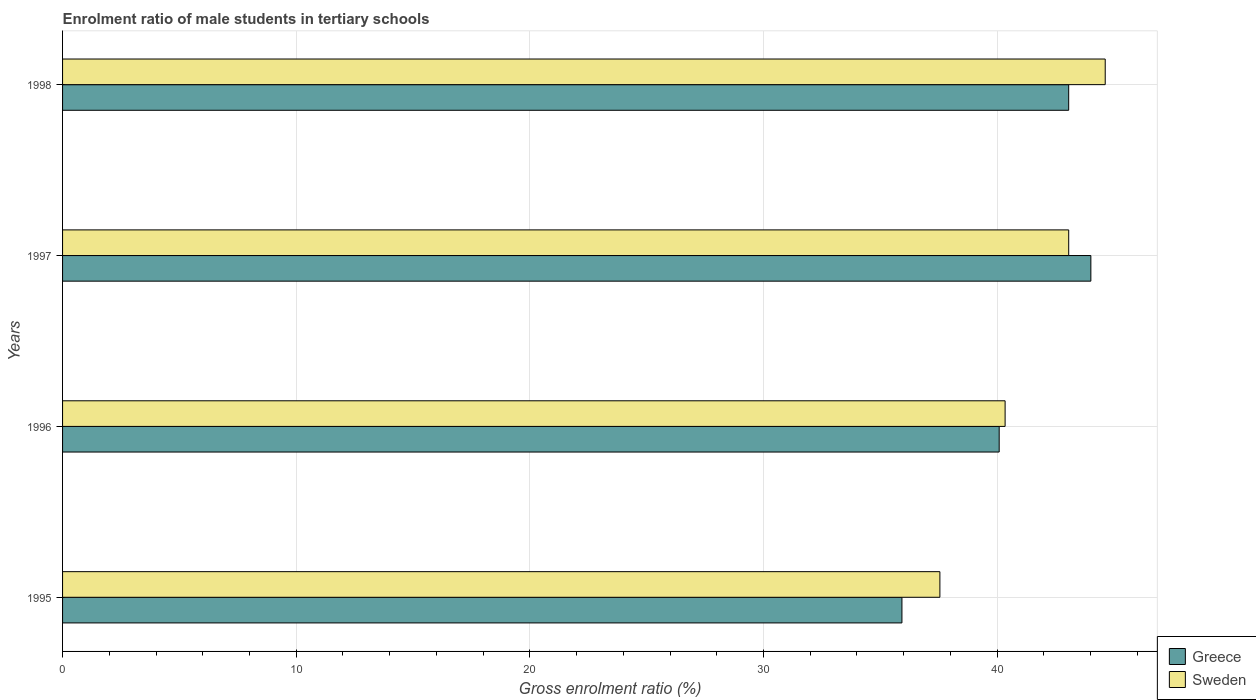How many different coloured bars are there?
Your response must be concise. 2. Are the number of bars per tick equal to the number of legend labels?
Offer a very short reply. Yes. How many bars are there on the 2nd tick from the top?
Provide a succinct answer. 2. What is the label of the 4th group of bars from the top?
Your answer should be compact. 1995. In how many cases, is the number of bars for a given year not equal to the number of legend labels?
Make the answer very short. 0. What is the enrolment ratio of male students in tertiary schools in Sweden in 1996?
Your answer should be compact. 40.34. Across all years, what is the maximum enrolment ratio of male students in tertiary schools in Greece?
Provide a succinct answer. 44.01. Across all years, what is the minimum enrolment ratio of male students in tertiary schools in Greece?
Ensure brevity in your answer.  35.93. In which year was the enrolment ratio of male students in tertiary schools in Greece minimum?
Give a very brief answer. 1995. What is the total enrolment ratio of male students in tertiary schools in Greece in the graph?
Your answer should be compact. 163.09. What is the difference between the enrolment ratio of male students in tertiary schools in Greece in 1996 and that in 1997?
Ensure brevity in your answer.  -3.92. What is the difference between the enrolment ratio of male students in tertiary schools in Sweden in 1995 and the enrolment ratio of male students in tertiary schools in Greece in 1998?
Provide a succinct answer. -5.51. What is the average enrolment ratio of male students in tertiary schools in Greece per year?
Ensure brevity in your answer.  40.77. In the year 1997, what is the difference between the enrolment ratio of male students in tertiary schools in Sweden and enrolment ratio of male students in tertiary schools in Greece?
Ensure brevity in your answer.  -0.95. In how many years, is the enrolment ratio of male students in tertiary schools in Sweden greater than 34 %?
Your answer should be very brief. 4. What is the ratio of the enrolment ratio of male students in tertiary schools in Sweden in 1996 to that in 1998?
Provide a succinct answer. 0.9. Is the enrolment ratio of male students in tertiary schools in Sweden in 1996 less than that in 1998?
Provide a succinct answer. Yes. Is the difference between the enrolment ratio of male students in tertiary schools in Sweden in 1996 and 1998 greater than the difference between the enrolment ratio of male students in tertiary schools in Greece in 1996 and 1998?
Your response must be concise. No. What is the difference between the highest and the second highest enrolment ratio of male students in tertiary schools in Sweden?
Offer a terse response. 1.56. What is the difference between the highest and the lowest enrolment ratio of male students in tertiary schools in Greece?
Your answer should be very brief. 8.09. Is the sum of the enrolment ratio of male students in tertiary schools in Greece in 1996 and 1998 greater than the maximum enrolment ratio of male students in tertiary schools in Sweden across all years?
Your answer should be compact. Yes. What does the 1st bar from the bottom in 1996 represents?
Provide a short and direct response. Greece. Are all the bars in the graph horizontal?
Keep it short and to the point. Yes. How many years are there in the graph?
Keep it short and to the point. 4. What is the difference between two consecutive major ticks on the X-axis?
Your answer should be very brief. 10. Are the values on the major ticks of X-axis written in scientific E-notation?
Make the answer very short. No. Does the graph contain grids?
Your response must be concise. Yes. How many legend labels are there?
Offer a very short reply. 2. How are the legend labels stacked?
Your answer should be very brief. Vertical. What is the title of the graph?
Offer a very short reply. Enrolment ratio of male students in tertiary schools. What is the label or title of the X-axis?
Make the answer very short. Gross enrolment ratio (%). What is the label or title of the Y-axis?
Provide a short and direct response. Years. What is the Gross enrolment ratio (%) in Greece in 1995?
Make the answer very short. 35.93. What is the Gross enrolment ratio (%) of Sweden in 1995?
Your response must be concise. 37.55. What is the Gross enrolment ratio (%) in Greece in 1996?
Provide a succinct answer. 40.09. What is the Gross enrolment ratio (%) of Sweden in 1996?
Provide a short and direct response. 40.34. What is the Gross enrolment ratio (%) of Greece in 1997?
Keep it short and to the point. 44.01. What is the Gross enrolment ratio (%) of Sweden in 1997?
Provide a short and direct response. 43.06. What is the Gross enrolment ratio (%) in Greece in 1998?
Provide a succinct answer. 43.06. What is the Gross enrolment ratio (%) in Sweden in 1998?
Provide a succinct answer. 44.63. Across all years, what is the maximum Gross enrolment ratio (%) in Greece?
Offer a terse response. 44.01. Across all years, what is the maximum Gross enrolment ratio (%) in Sweden?
Offer a very short reply. 44.63. Across all years, what is the minimum Gross enrolment ratio (%) of Greece?
Your answer should be compact. 35.93. Across all years, what is the minimum Gross enrolment ratio (%) in Sweden?
Provide a short and direct response. 37.55. What is the total Gross enrolment ratio (%) of Greece in the graph?
Provide a short and direct response. 163.09. What is the total Gross enrolment ratio (%) in Sweden in the graph?
Make the answer very short. 165.58. What is the difference between the Gross enrolment ratio (%) in Greece in 1995 and that in 1996?
Provide a succinct answer. -4.16. What is the difference between the Gross enrolment ratio (%) of Sweden in 1995 and that in 1996?
Your answer should be compact. -2.79. What is the difference between the Gross enrolment ratio (%) of Greece in 1995 and that in 1997?
Give a very brief answer. -8.09. What is the difference between the Gross enrolment ratio (%) of Sweden in 1995 and that in 1997?
Make the answer very short. -5.51. What is the difference between the Gross enrolment ratio (%) of Greece in 1995 and that in 1998?
Make the answer very short. -7.14. What is the difference between the Gross enrolment ratio (%) in Sweden in 1995 and that in 1998?
Your response must be concise. -7.08. What is the difference between the Gross enrolment ratio (%) of Greece in 1996 and that in 1997?
Provide a succinct answer. -3.92. What is the difference between the Gross enrolment ratio (%) of Sweden in 1996 and that in 1997?
Make the answer very short. -2.72. What is the difference between the Gross enrolment ratio (%) of Greece in 1996 and that in 1998?
Make the answer very short. -2.97. What is the difference between the Gross enrolment ratio (%) of Sweden in 1996 and that in 1998?
Give a very brief answer. -4.28. What is the difference between the Gross enrolment ratio (%) in Greece in 1997 and that in 1998?
Ensure brevity in your answer.  0.95. What is the difference between the Gross enrolment ratio (%) of Sweden in 1997 and that in 1998?
Provide a succinct answer. -1.56. What is the difference between the Gross enrolment ratio (%) of Greece in 1995 and the Gross enrolment ratio (%) of Sweden in 1996?
Keep it short and to the point. -4.42. What is the difference between the Gross enrolment ratio (%) in Greece in 1995 and the Gross enrolment ratio (%) in Sweden in 1997?
Your answer should be compact. -7.14. What is the difference between the Gross enrolment ratio (%) in Greece in 1995 and the Gross enrolment ratio (%) in Sweden in 1998?
Provide a succinct answer. -8.7. What is the difference between the Gross enrolment ratio (%) of Greece in 1996 and the Gross enrolment ratio (%) of Sweden in 1997?
Keep it short and to the point. -2.98. What is the difference between the Gross enrolment ratio (%) of Greece in 1996 and the Gross enrolment ratio (%) of Sweden in 1998?
Offer a very short reply. -4.54. What is the difference between the Gross enrolment ratio (%) in Greece in 1997 and the Gross enrolment ratio (%) in Sweden in 1998?
Provide a succinct answer. -0.61. What is the average Gross enrolment ratio (%) of Greece per year?
Keep it short and to the point. 40.77. What is the average Gross enrolment ratio (%) in Sweden per year?
Offer a very short reply. 41.4. In the year 1995, what is the difference between the Gross enrolment ratio (%) in Greece and Gross enrolment ratio (%) in Sweden?
Offer a very short reply. -1.62. In the year 1996, what is the difference between the Gross enrolment ratio (%) in Greece and Gross enrolment ratio (%) in Sweden?
Your response must be concise. -0.25. In the year 1997, what is the difference between the Gross enrolment ratio (%) of Greece and Gross enrolment ratio (%) of Sweden?
Make the answer very short. 0.95. In the year 1998, what is the difference between the Gross enrolment ratio (%) in Greece and Gross enrolment ratio (%) in Sweden?
Your response must be concise. -1.56. What is the ratio of the Gross enrolment ratio (%) of Greece in 1995 to that in 1996?
Your response must be concise. 0.9. What is the ratio of the Gross enrolment ratio (%) of Sweden in 1995 to that in 1996?
Your answer should be very brief. 0.93. What is the ratio of the Gross enrolment ratio (%) of Greece in 1995 to that in 1997?
Provide a short and direct response. 0.82. What is the ratio of the Gross enrolment ratio (%) of Sweden in 1995 to that in 1997?
Ensure brevity in your answer.  0.87. What is the ratio of the Gross enrolment ratio (%) in Greece in 1995 to that in 1998?
Give a very brief answer. 0.83. What is the ratio of the Gross enrolment ratio (%) of Sweden in 1995 to that in 1998?
Give a very brief answer. 0.84. What is the ratio of the Gross enrolment ratio (%) of Greece in 1996 to that in 1997?
Make the answer very short. 0.91. What is the ratio of the Gross enrolment ratio (%) of Sweden in 1996 to that in 1997?
Your answer should be compact. 0.94. What is the ratio of the Gross enrolment ratio (%) in Greece in 1996 to that in 1998?
Offer a terse response. 0.93. What is the ratio of the Gross enrolment ratio (%) in Sweden in 1996 to that in 1998?
Your answer should be very brief. 0.9. What is the ratio of the Gross enrolment ratio (%) in Greece in 1997 to that in 1998?
Give a very brief answer. 1.02. What is the difference between the highest and the second highest Gross enrolment ratio (%) in Greece?
Your answer should be very brief. 0.95. What is the difference between the highest and the second highest Gross enrolment ratio (%) in Sweden?
Your response must be concise. 1.56. What is the difference between the highest and the lowest Gross enrolment ratio (%) in Greece?
Your response must be concise. 8.09. What is the difference between the highest and the lowest Gross enrolment ratio (%) in Sweden?
Your response must be concise. 7.08. 